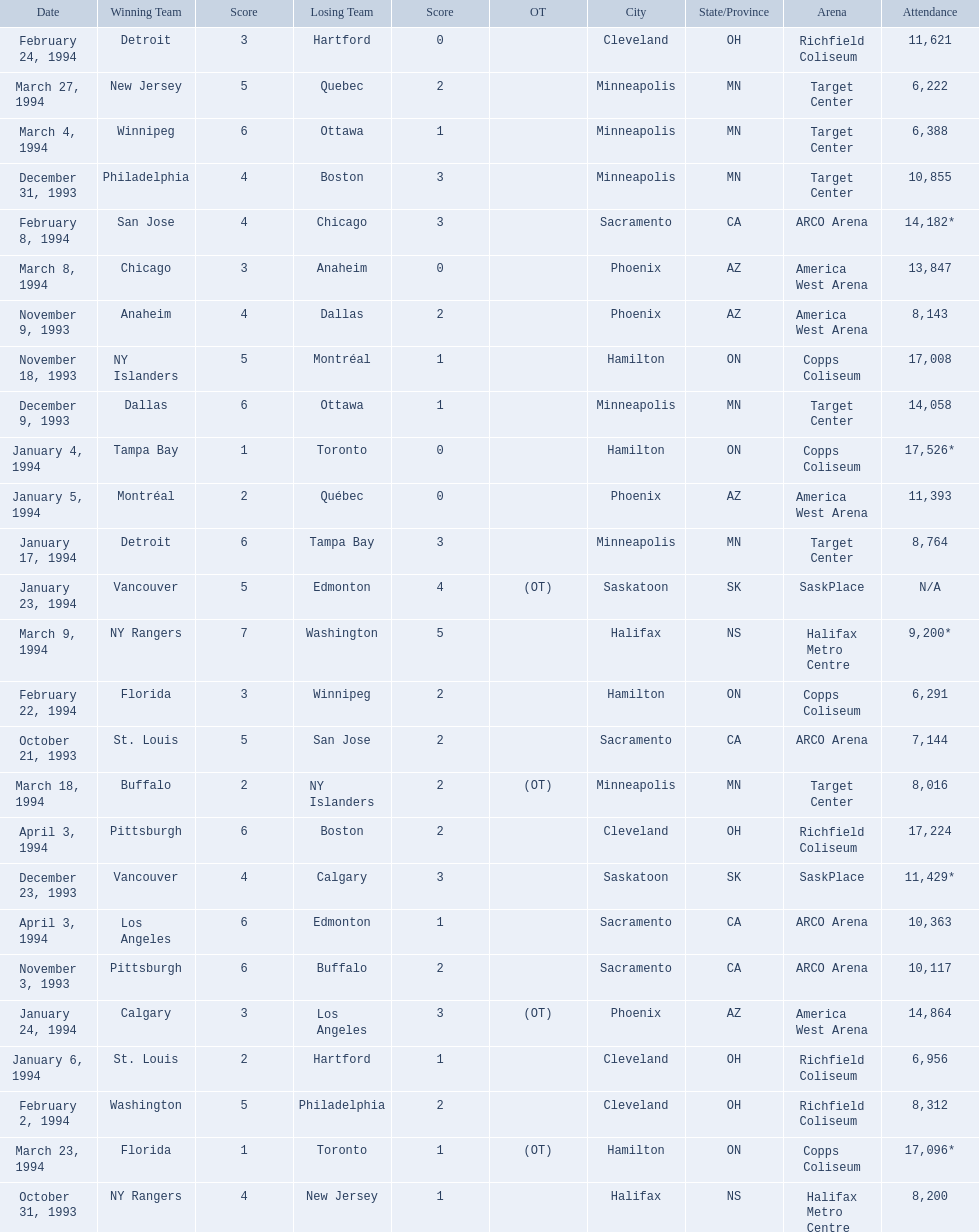When were the games played? October 21, 1993, October 31, 1993, November 3, 1993, November 9, 1993, November 18, 1993, December 9, 1993, December 23, 1993, December 31, 1993, January 4, 1994, January 5, 1994, January 6, 1994, January 17, 1994, January 23, 1994, January 24, 1994, February 2, 1994, February 8, 1994, February 22, 1994, February 24, 1994, March 4, 1994, March 8, 1994, March 9, 1994, March 18, 1994, March 23, 1994, March 27, 1994, April 3, 1994, April 3, 1994. What was the attendance for those games? 7,144, 8,200, 10,117, 8,143, 17,008, 14,058, 11,429*, 10,855, 17,526*, 11,393, 6,956, 8,764, N/A, 14,864, 8,312, 14,182*, 6,291, 11,621, 6,388, 13,847, 9,200*, 8,016, 17,096*, 6,222, 17,224, 10,363. Which date had the highest attendance? January 4, 1994. 